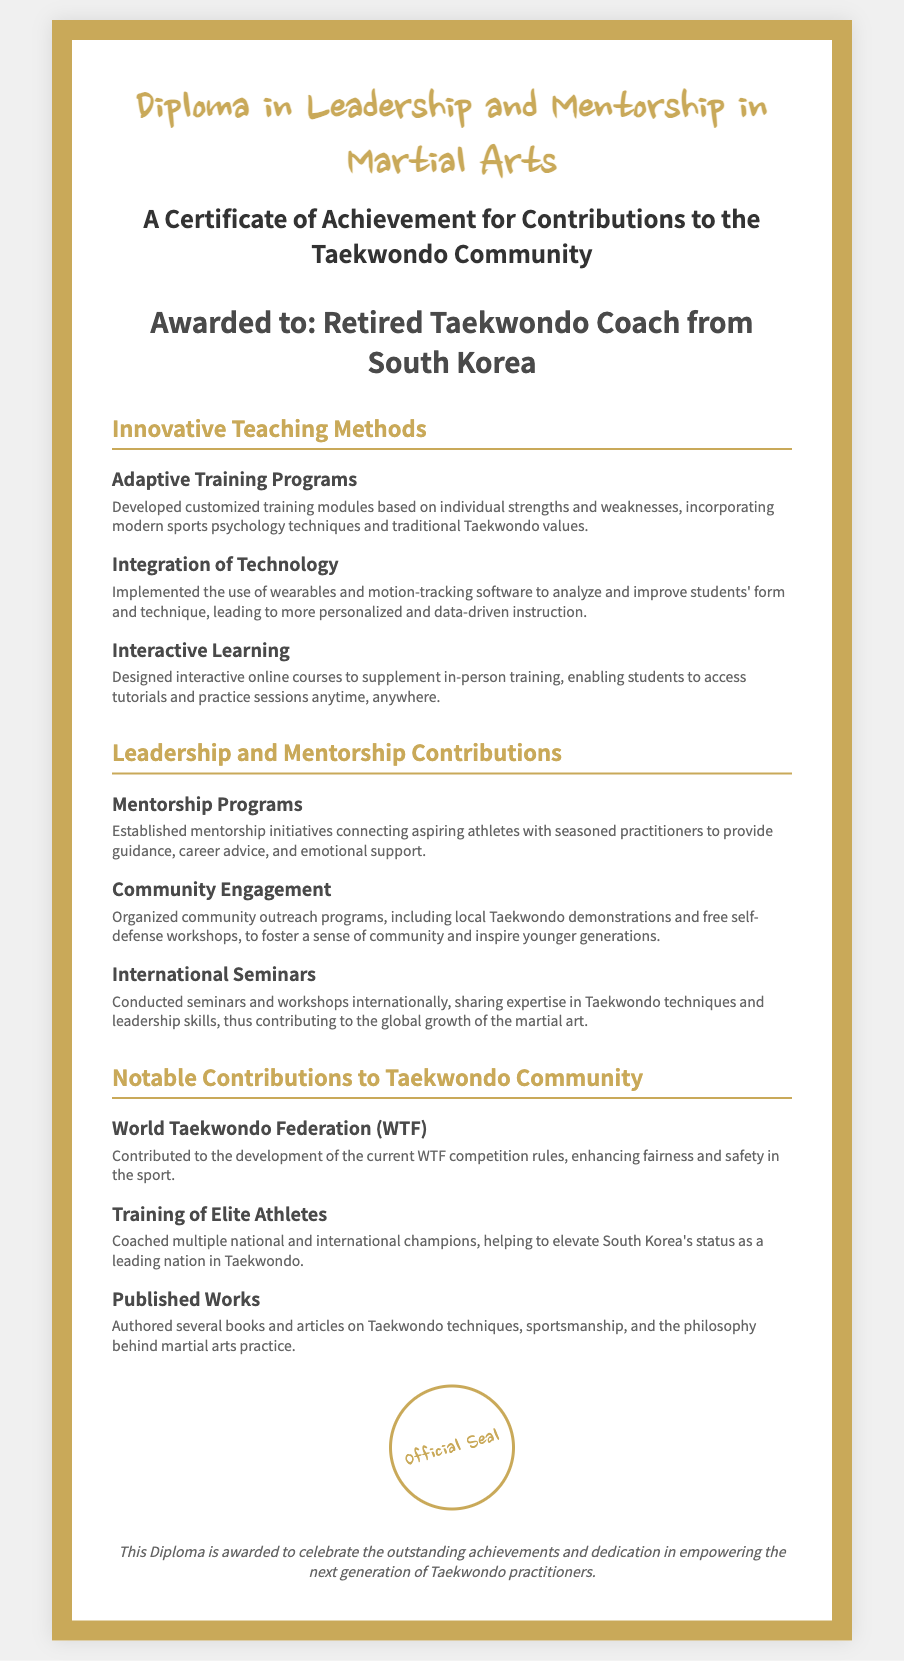what is the title of the diploma? The title of the diploma can be found at the top of the document, stating the focus of the credential awarded.
Answer: Diploma in Leadership and Mentorship in Martial Arts who is the recipient of the diploma? The recipient is specifically named in the section dedicated to acknowledging the individual receiving the award.
Answer: Retired Taekwondo Coach from South Korea what is one innovative teaching method mentioned in the document? The document lists several methods; one example can be found under the section for innovative teaching.
Answer: Adaptive Training Programs what community outreach program is mentioned in the contributions section? The contributions section details various initiatives aimed at improving community relations through Taekwondo.
Answer: Local Taekwondo demonstrations which organization’s competition rules did the recipient contribute to? A significant portion of the document discusses contributions made to established organizations in Taekwondo.
Answer: World Taekwondo Federation (WTF) how many areas of contributions to the Taekwondo community are listed? The document comprises different sections including leadership, mentorship, and contributions, which help identify the number.
Answer: Three what type of courses did the recipient design? This refers to a specific method of teaching that was introduced by the recipient for broader access to learning.
Answer: Interactive online courses how are the mentorship programs described? A specific characteristic or element of the mentorship programs can be derived from a detailed explanation within the document.
Answer: Connecting aspiring athletes with seasoned practitioners what are the author’s contributions to Taekwondo literature? This aspect focuses on the impacts the recipient has had in sharing knowledge through written works.
Answer: Authored several books and articles 